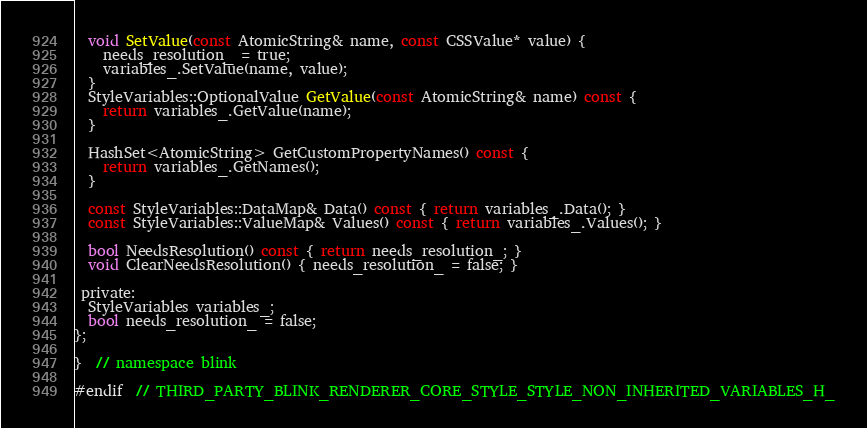<code> <loc_0><loc_0><loc_500><loc_500><_C_>  void SetValue(const AtomicString& name, const CSSValue* value) {
    needs_resolution_ = true;
    variables_.SetValue(name, value);
  }
  StyleVariables::OptionalValue GetValue(const AtomicString& name) const {
    return variables_.GetValue(name);
  }

  HashSet<AtomicString> GetCustomPropertyNames() const {
    return variables_.GetNames();
  }

  const StyleVariables::DataMap& Data() const { return variables_.Data(); }
  const StyleVariables::ValueMap& Values() const { return variables_.Values(); }

  bool NeedsResolution() const { return needs_resolution_; }
  void ClearNeedsResolution() { needs_resolution_ = false; }

 private:
  StyleVariables variables_;
  bool needs_resolution_ = false;
};

}  // namespace blink

#endif  // THIRD_PARTY_BLINK_RENDERER_CORE_STYLE_STYLE_NON_INHERITED_VARIABLES_H_
</code> 